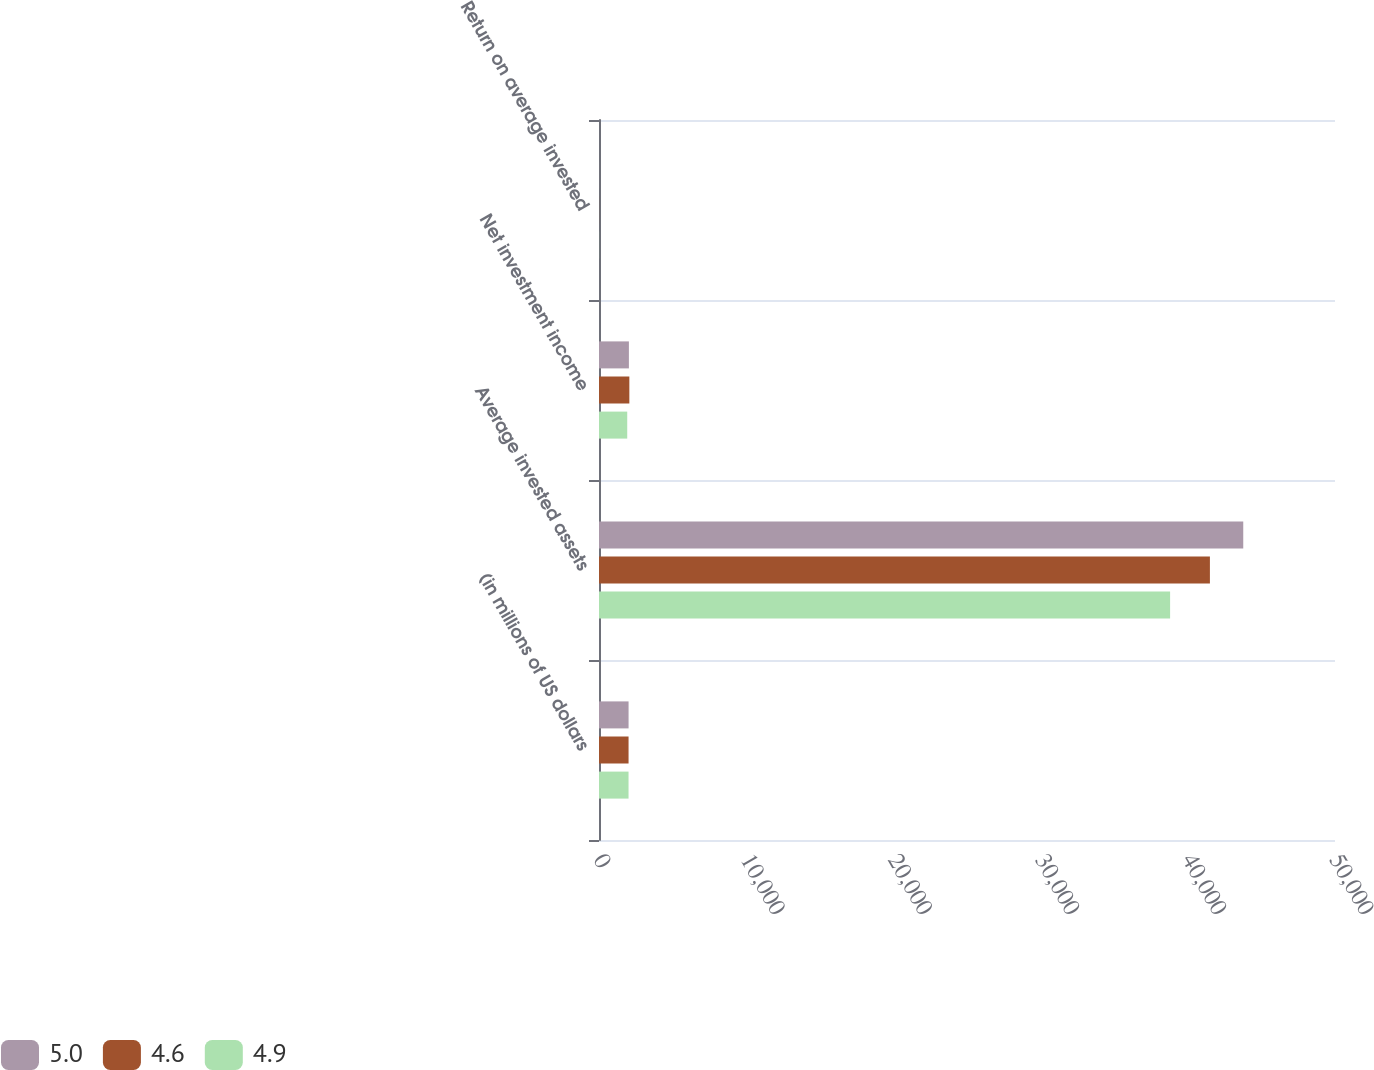Convert chart. <chart><loc_0><loc_0><loc_500><loc_500><stacked_bar_chart><ecel><fcel>(in millions of US dollars<fcel>Average invested assets<fcel>Net investment income<fcel>Return on average invested<nl><fcel>5<fcel>2009<fcel>43767<fcel>2031<fcel>4.6<nl><fcel>4.6<fcel>2008<fcel>41502<fcel>2062<fcel>5<nl><fcel>4.9<fcel>2007<fcel>38798<fcel>1918<fcel>4.9<nl></chart> 